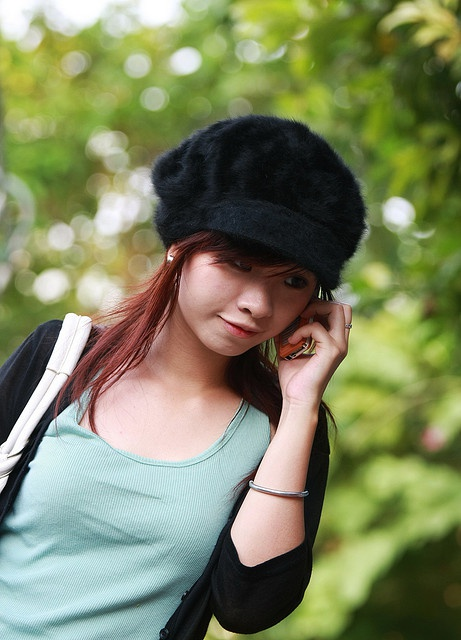Describe the objects in this image and their specific colors. I can see people in white, black, lightgray, lightblue, and brown tones, handbag in white, black, darkgray, and gray tones, and cell phone in white, black, maroon, and brown tones in this image. 